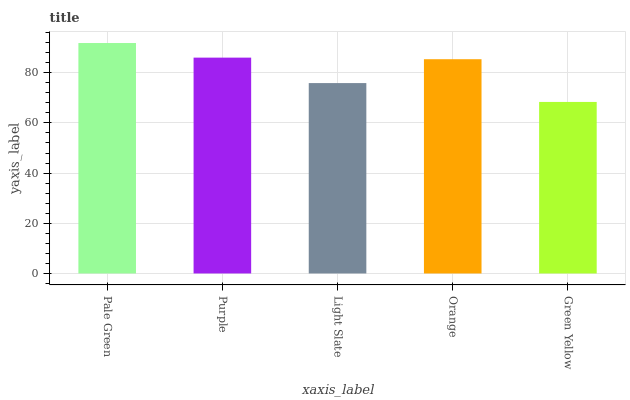Is Green Yellow the minimum?
Answer yes or no. Yes. Is Pale Green the maximum?
Answer yes or no. Yes. Is Purple the minimum?
Answer yes or no. No. Is Purple the maximum?
Answer yes or no. No. Is Pale Green greater than Purple?
Answer yes or no. Yes. Is Purple less than Pale Green?
Answer yes or no. Yes. Is Purple greater than Pale Green?
Answer yes or no. No. Is Pale Green less than Purple?
Answer yes or no. No. Is Orange the high median?
Answer yes or no. Yes. Is Orange the low median?
Answer yes or no. Yes. Is Green Yellow the high median?
Answer yes or no. No. Is Purple the low median?
Answer yes or no. No. 